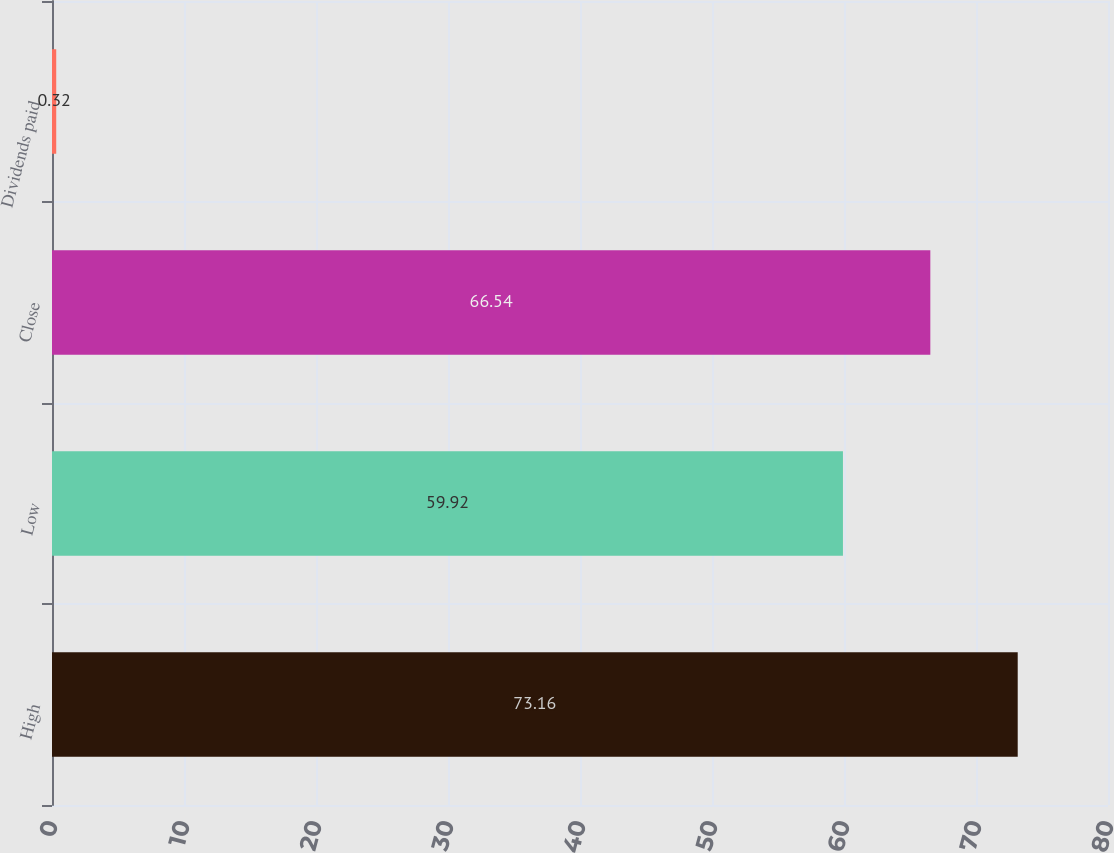<chart> <loc_0><loc_0><loc_500><loc_500><bar_chart><fcel>High<fcel>Low<fcel>Close<fcel>Dividends paid<nl><fcel>73.16<fcel>59.92<fcel>66.54<fcel>0.32<nl></chart> 